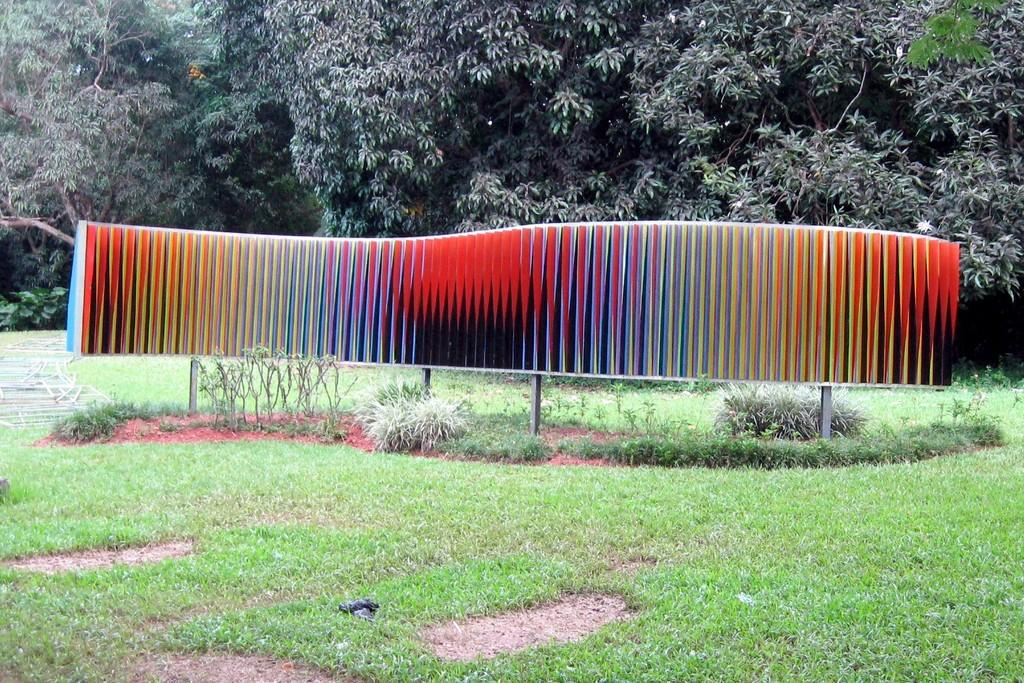What is the colorful object in the image? The facts do not specify the type of colorful object in the image. What can be seen besides the colorful object in the image? There are rods, plants, grass, and other unspecified objects in the image. What is present in the background of the image? The background of the image contains trees and plants. What type of net is being used to catch the spring in the image? There is no net or spring present in the image. 